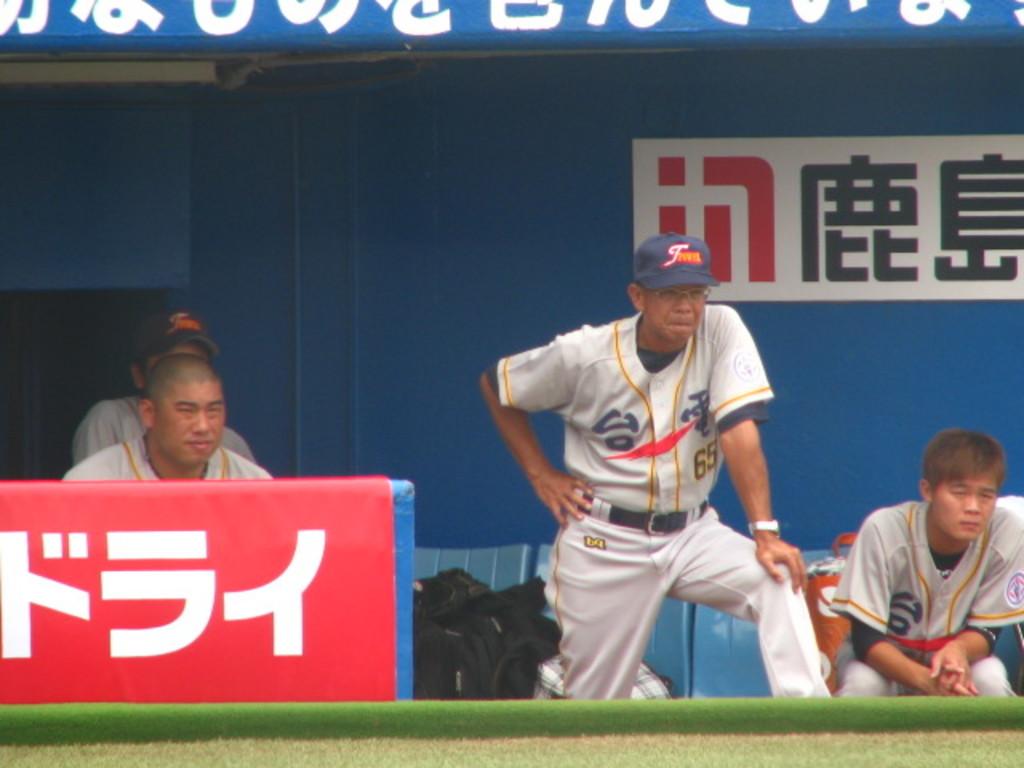What is the number of the man standing in the middle?
Offer a very short reply. 65. 